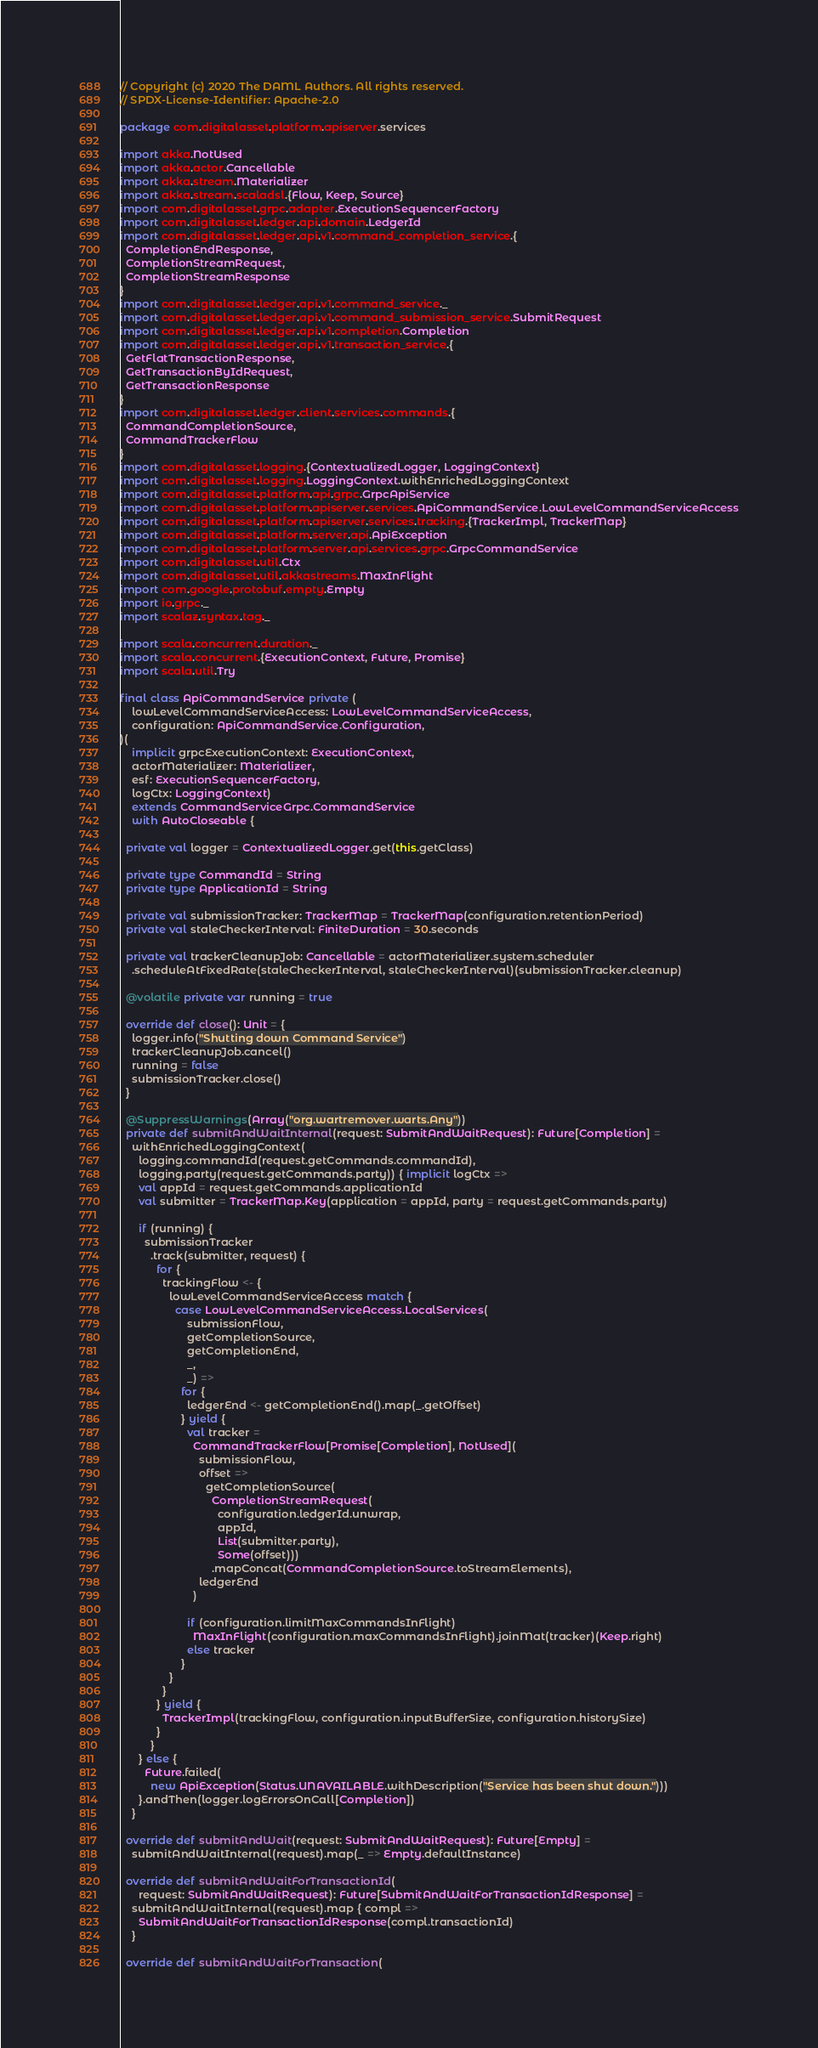<code> <loc_0><loc_0><loc_500><loc_500><_Scala_>// Copyright (c) 2020 The DAML Authors. All rights reserved.
// SPDX-License-Identifier: Apache-2.0

package com.digitalasset.platform.apiserver.services

import akka.NotUsed
import akka.actor.Cancellable
import akka.stream.Materializer
import akka.stream.scaladsl.{Flow, Keep, Source}
import com.digitalasset.grpc.adapter.ExecutionSequencerFactory
import com.digitalasset.ledger.api.domain.LedgerId
import com.digitalasset.ledger.api.v1.command_completion_service.{
  CompletionEndResponse,
  CompletionStreamRequest,
  CompletionStreamResponse
}
import com.digitalasset.ledger.api.v1.command_service._
import com.digitalasset.ledger.api.v1.command_submission_service.SubmitRequest
import com.digitalasset.ledger.api.v1.completion.Completion
import com.digitalasset.ledger.api.v1.transaction_service.{
  GetFlatTransactionResponse,
  GetTransactionByIdRequest,
  GetTransactionResponse
}
import com.digitalasset.ledger.client.services.commands.{
  CommandCompletionSource,
  CommandTrackerFlow
}
import com.digitalasset.logging.{ContextualizedLogger, LoggingContext}
import com.digitalasset.logging.LoggingContext.withEnrichedLoggingContext
import com.digitalasset.platform.api.grpc.GrpcApiService
import com.digitalasset.platform.apiserver.services.ApiCommandService.LowLevelCommandServiceAccess
import com.digitalasset.platform.apiserver.services.tracking.{TrackerImpl, TrackerMap}
import com.digitalasset.platform.server.api.ApiException
import com.digitalasset.platform.server.api.services.grpc.GrpcCommandService
import com.digitalasset.util.Ctx
import com.digitalasset.util.akkastreams.MaxInFlight
import com.google.protobuf.empty.Empty
import io.grpc._
import scalaz.syntax.tag._

import scala.concurrent.duration._
import scala.concurrent.{ExecutionContext, Future, Promise}
import scala.util.Try

final class ApiCommandService private (
    lowLevelCommandServiceAccess: LowLevelCommandServiceAccess,
    configuration: ApiCommandService.Configuration,
)(
    implicit grpcExecutionContext: ExecutionContext,
    actorMaterializer: Materializer,
    esf: ExecutionSequencerFactory,
    logCtx: LoggingContext)
    extends CommandServiceGrpc.CommandService
    with AutoCloseable {

  private val logger = ContextualizedLogger.get(this.getClass)

  private type CommandId = String
  private type ApplicationId = String

  private val submissionTracker: TrackerMap = TrackerMap(configuration.retentionPeriod)
  private val staleCheckerInterval: FiniteDuration = 30.seconds

  private val trackerCleanupJob: Cancellable = actorMaterializer.system.scheduler
    .scheduleAtFixedRate(staleCheckerInterval, staleCheckerInterval)(submissionTracker.cleanup)

  @volatile private var running = true

  override def close(): Unit = {
    logger.info("Shutting down Command Service")
    trackerCleanupJob.cancel()
    running = false
    submissionTracker.close()
  }

  @SuppressWarnings(Array("org.wartremover.warts.Any"))
  private def submitAndWaitInternal(request: SubmitAndWaitRequest): Future[Completion] =
    withEnrichedLoggingContext(
      logging.commandId(request.getCommands.commandId),
      logging.party(request.getCommands.party)) { implicit logCtx =>
      val appId = request.getCommands.applicationId
      val submitter = TrackerMap.Key(application = appId, party = request.getCommands.party)

      if (running) {
        submissionTracker
          .track(submitter, request) {
            for {
              trackingFlow <- {
                lowLevelCommandServiceAccess match {
                  case LowLevelCommandServiceAccess.LocalServices(
                      submissionFlow,
                      getCompletionSource,
                      getCompletionEnd,
                      _,
                      _) =>
                    for {
                      ledgerEnd <- getCompletionEnd().map(_.getOffset)
                    } yield {
                      val tracker =
                        CommandTrackerFlow[Promise[Completion], NotUsed](
                          submissionFlow,
                          offset =>
                            getCompletionSource(
                              CompletionStreamRequest(
                                configuration.ledgerId.unwrap,
                                appId,
                                List(submitter.party),
                                Some(offset)))
                              .mapConcat(CommandCompletionSource.toStreamElements),
                          ledgerEnd
                        )

                      if (configuration.limitMaxCommandsInFlight)
                        MaxInFlight(configuration.maxCommandsInFlight).joinMat(tracker)(Keep.right)
                      else tracker
                    }
                }
              }
            } yield {
              TrackerImpl(trackingFlow, configuration.inputBufferSize, configuration.historySize)
            }
          }
      } else {
        Future.failed(
          new ApiException(Status.UNAVAILABLE.withDescription("Service has been shut down.")))
      }.andThen(logger.logErrorsOnCall[Completion])
    }

  override def submitAndWait(request: SubmitAndWaitRequest): Future[Empty] =
    submitAndWaitInternal(request).map(_ => Empty.defaultInstance)

  override def submitAndWaitForTransactionId(
      request: SubmitAndWaitRequest): Future[SubmitAndWaitForTransactionIdResponse] =
    submitAndWaitInternal(request).map { compl =>
      SubmitAndWaitForTransactionIdResponse(compl.transactionId)
    }

  override def submitAndWaitForTransaction(</code> 